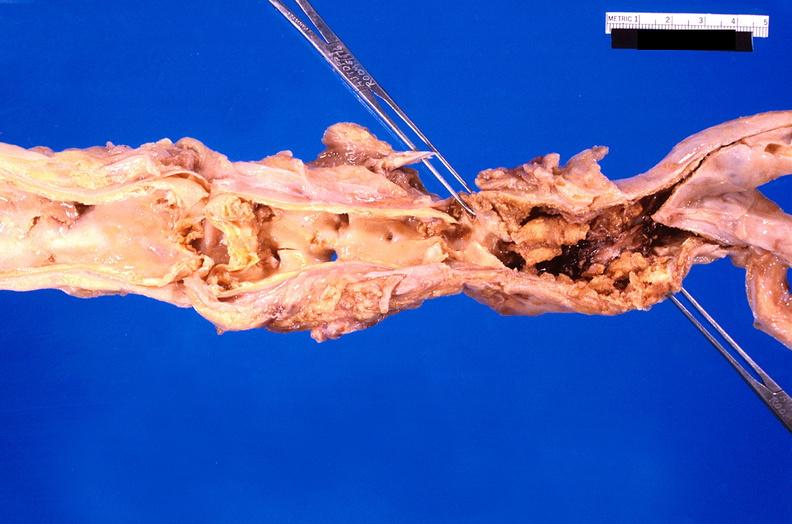does this image show abdominal aorta saccular aneurysm, atherosclerosis?
Answer the question using a single word or phrase. Yes 